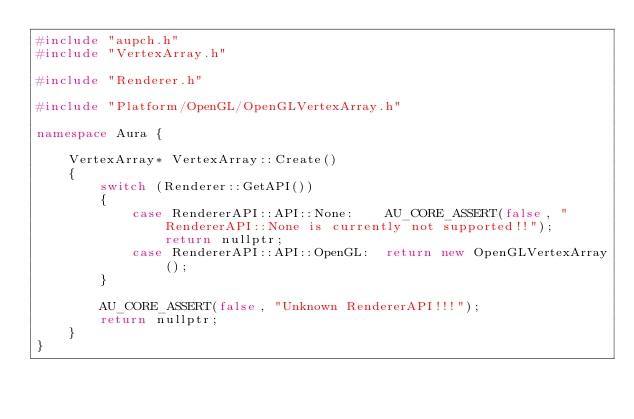<code> <loc_0><loc_0><loc_500><loc_500><_C++_>#include "aupch.h"
#include "VertexArray.h"

#include "Renderer.h"

#include "Platform/OpenGL/OpenGLVertexArray.h"

namespace Aura {

	VertexArray* VertexArray::Create()
	{
		switch (Renderer::GetAPI())
		{
			case RendererAPI::API::None:    AU_CORE_ASSERT(false, "RendererAPI::None is currently not supported!!"); return nullptr;
			case RendererAPI::API::OpenGL:  return new OpenGLVertexArray();
		}

		AU_CORE_ASSERT(false, "Unknown RendererAPI!!!");
		return nullptr;
	}
}</code> 